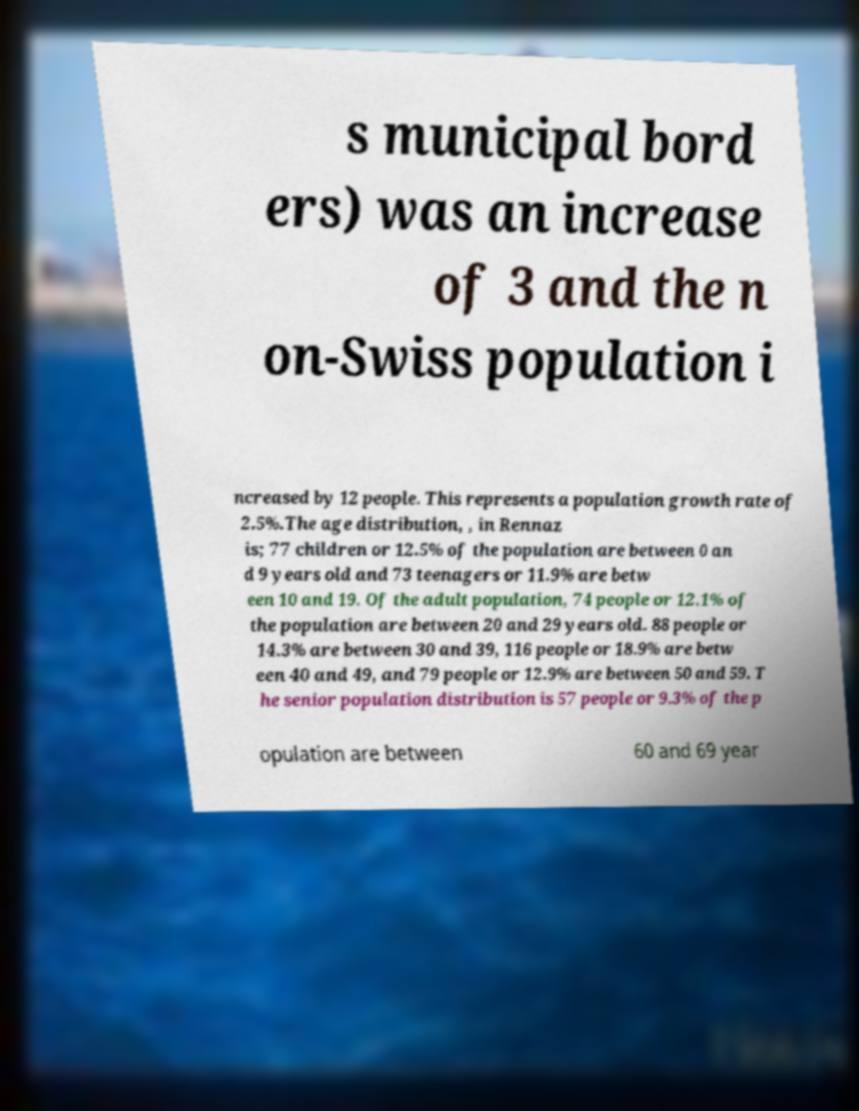Can you read and provide the text displayed in the image?This photo seems to have some interesting text. Can you extract and type it out for me? s municipal bord ers) was an increase of 3 and the n on-Swiss population i ncreased by 12 people. This represents a population growth rate of 2.5%.The age distribution, , in Rennaz is; 77 children or 12.5% of the population are between 0 an d 9 years old and 73 teenagers or 11.9% are betw een 10 and 19. Of the adult population, 74 people or 12.1% of the population are between 20 and 29 years old. 88 people or 14.3% are between 30 and 39, 116 people or 18.9% are betw een 40 and 49, and 79 people or 12.9% are between 50 and 59. T he senior population distribution is 57 people or 9.3% of the p opulation are between 60 and 69 year 